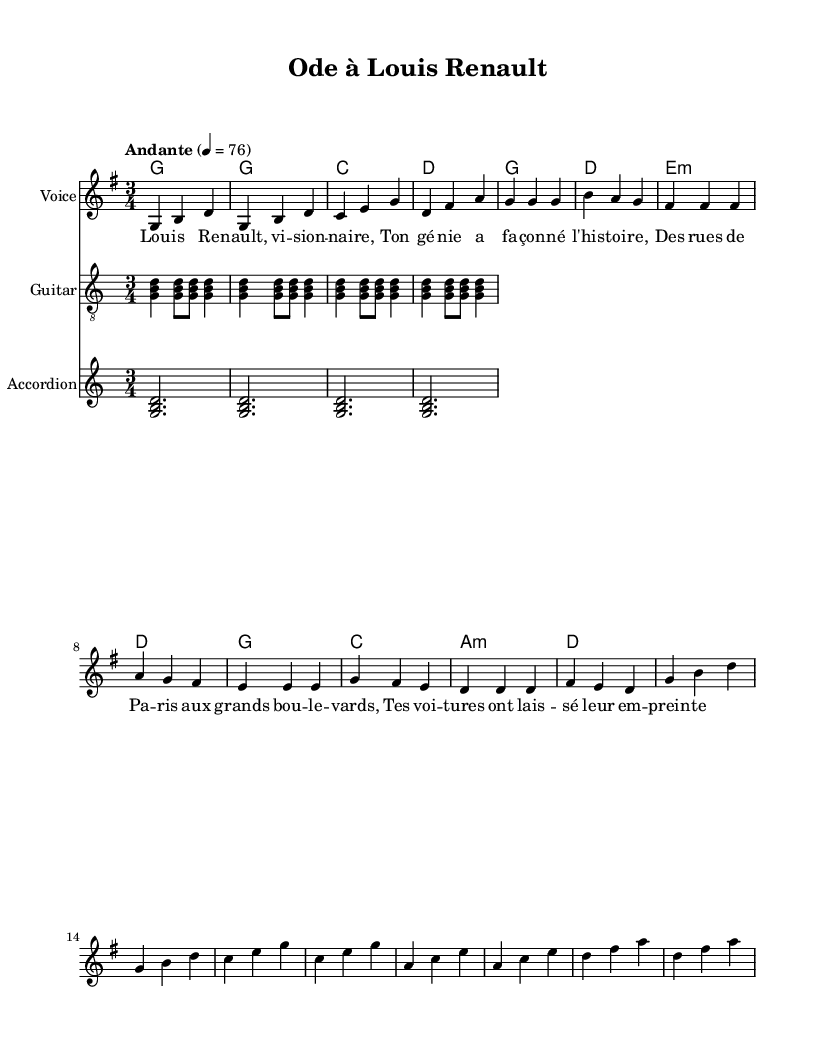What is the key signature of this music? The key signature is defined at the beginning of the score. In the global setup, it specifies "g \major," which means it has one sharp (F#).
Answer: g major What is the time signature of this music? The time signature is also found in the global setup at the beginning, indicated as "3/4," which means there are three beats in a measure.
Answer: 3/4 What is the tempo marking for this piece? The tempo marking is found in the global section, which states "Andante" with a metronome marking of 4 = 76, indicating a moderate pace.
Answer: Andante How many measures are present in the melody? To find the number of measures, we can count the bar lines in the melody section. There are 16 measures total in the melody notation, as indicated by the repeated structure and the final bar line.
Answer: 16 What is the first note of the melody? The first note in the melody, as shown in the notation, is "g," which is represented directly in the musical staff.
Answer: g What types of instruments are included in this score? This score features multiple staves; specifically, it includes Voice, Guitar, and Accordion. These instruments are denoted under separate staves in the score layout.
Answer: Voice, Guitar, Accordion Which chord is played in the intro? The chords are indicated in the harmony section. The intro section starts with a "g" chord, as specified at the beginning of the harmonies.
Answer: g 